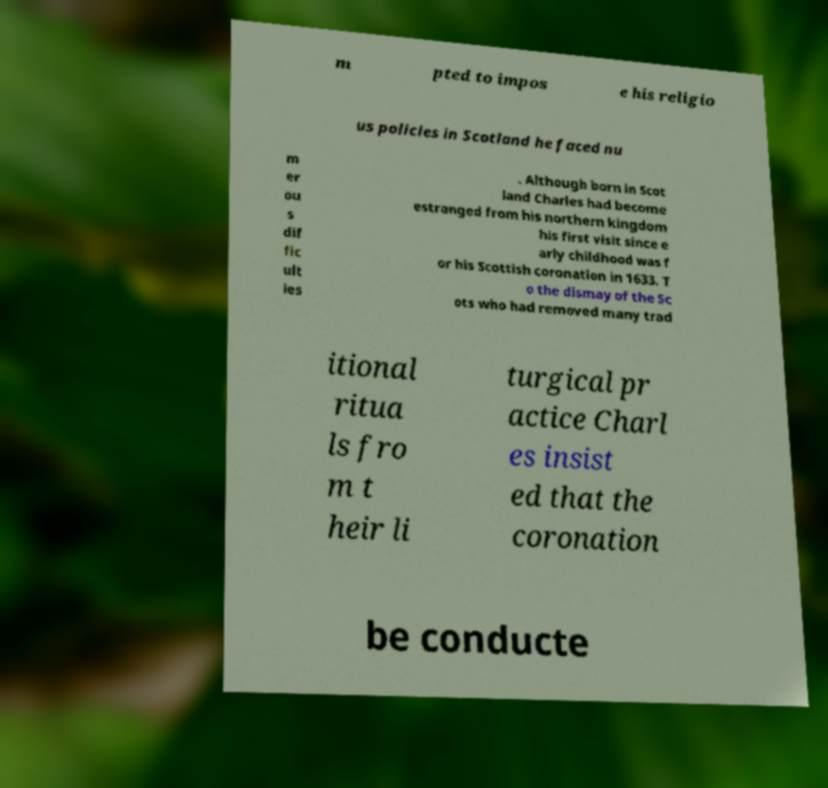Can you read and provide the text displayed in the image?This photo seems to have some interesting text. Can you extract and type it out for me? m pted to impos e his religio us policies in Scotland he faced nu m er ou s dif fic ult ies . Although born in Scot land Charles had become estranged from his northern kingdom his first visit since e arly childhood was f or his Scottish coronation in 1633. T o the dismay of the Sc ots who had removed many trad itional ritua ls fro m t heir li turgical pr actice Charl es insist ed that the coronation be conducte 